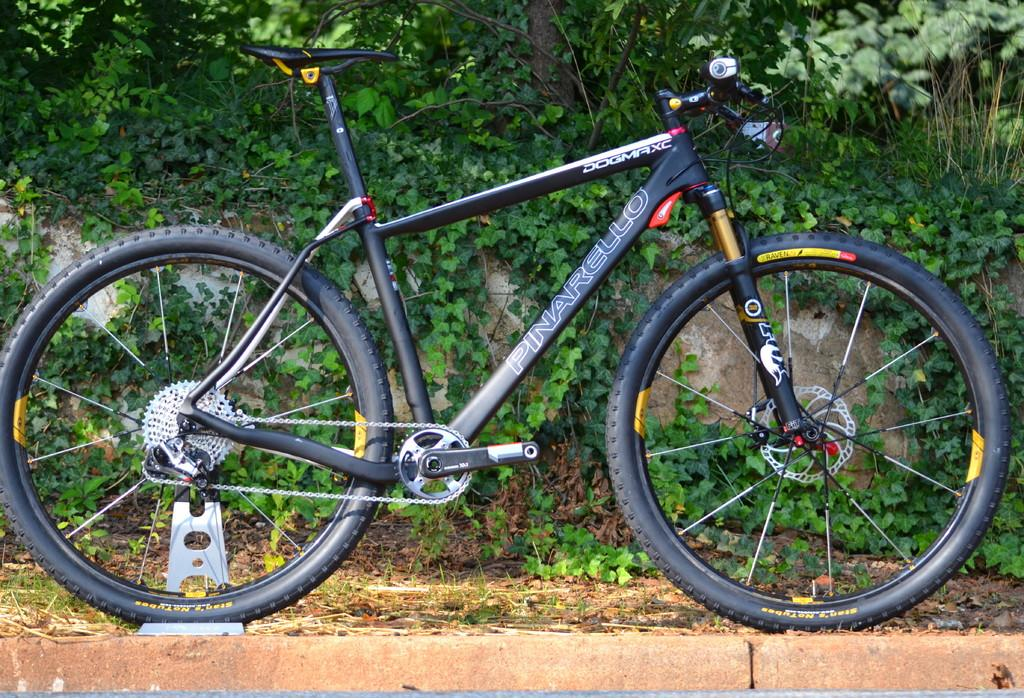What color is the bicycle in the image? The bicycle in the image is black. Where is the bicycle located? The bicycle is parked on the footpath. What can be seen in the background of the image? There are green leaves and plants visible in the background of the image. How many fish are swimming in the bicycle's basket in the image? There are no fish present in the image, and the bicycle does not have a basket. 